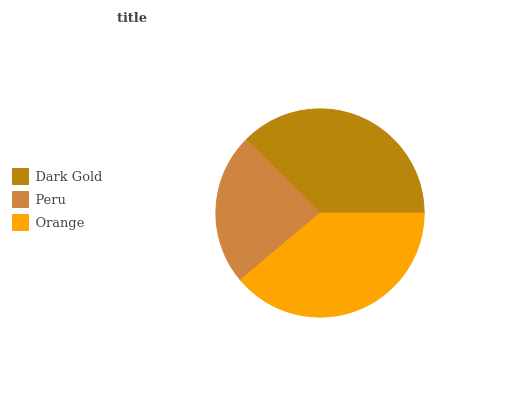Is Peru the minimum?
Answer yes or no. Yes. Is Orange the maximum?
Answer yes or no. Yes. Is Orange the minimum?
Answer yes or no. No. Is Peru the maximum?
Answer yes or no. No. Is Orange greater than Peru?
Answer yes or no. Yes. Is Peru less than Orange?
Answer yes or no. Yes. Is Peru greater than Orange?
Answer yes or no. No. Is Orange less than Peru?
Answer yes or no. No. Is Dark Gold the high median?
Answer yes or no. Yes. Is Dark Gold the low median?
Answer yes or no. Yes. Is Orange the high median?
Answer yes or no. No. Is Peru the low median?
Answer yes or no. No. 